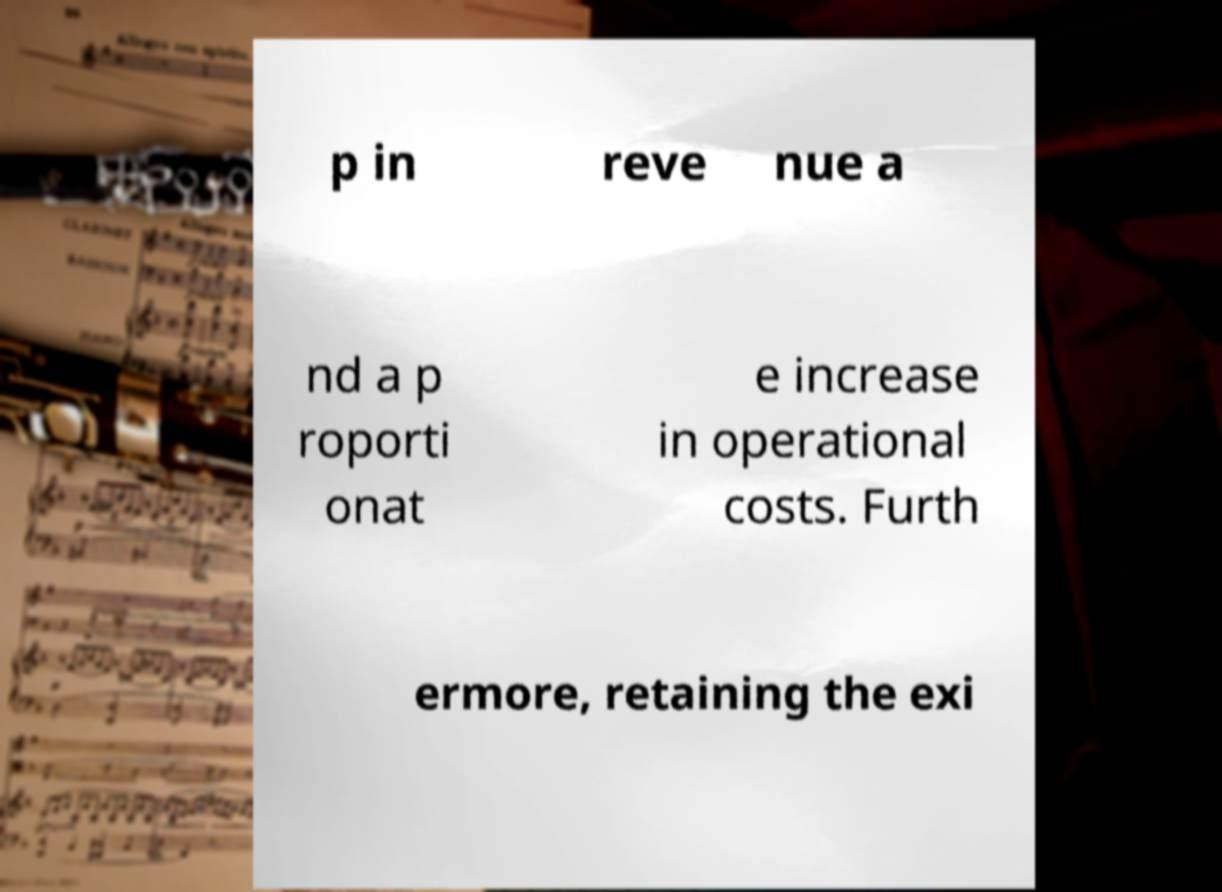Please identify and transcribe the text found in this image. p in reve nue a nd a p roporti onat e increase in operational costs. Furth ermore, retaining the exi 